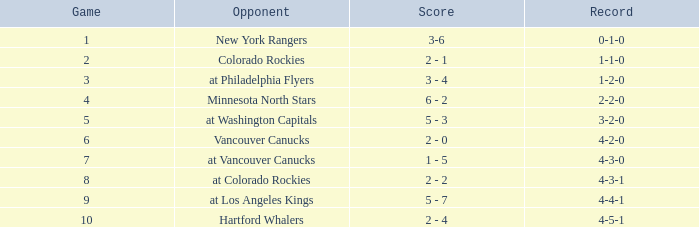What is the score for the opponent Vancouver Canucks? 2 - 0. 